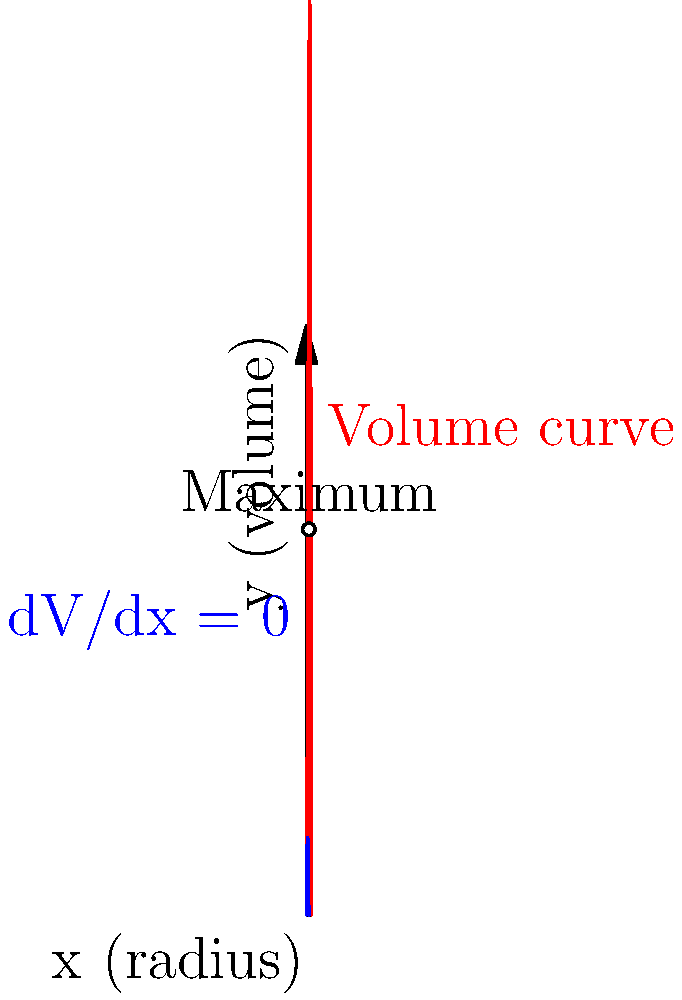A baby bottle manufacturer wants to design a cylindrical bottle with a maximum volume of 1000 mL. The total height and radius of the bottle are constrained such that $h + 2r = 10$ cm, where $h$ is the height and $r$ is the radius. Using calculus, determine the optimal dimensions (radius and height) of the bottle to maximize its volume. Round your answer to the nearest 0.1 cm. Let's approach this step-by-step:

1) The volume of a cylinder is given by $V = \pi r^2 h$.

2) We know that $h + 2r = 10$, so $h = 10 - 2r$.

3) Substituting this into the volume equation:
   $V = \pi r^2 (10 - 2r) = 10\pi r^2 - 2\pi r^3$

4) To find the maximum volume, we need to find where $\frac{dV}{dr} = 0$:
   $\frac{dV}{dr} = 20\pi r - 6\pi r^2$

5) Setting this equal to zero:
   $20\pi r - 6\pi r^2 = 0$
   $2r(10 - 3r) = 0$

6) Solving this equation:
   $r = 0$ or $r = \frac{10}{3}$

7) $r = 0$ would give us no volume, so the maximum must occur at $r = \frac{10}{3} \approx 3.33$ cm.

8) To find the height, we use $h = 10 - 2r$:
   $h = 10 - 2(\frac{10}{3}) = \frac{10}{3} \approx 3.33$ cm

9) Rounding to the nearest 0.1 cm:
   $r \approx 3.3$ cm and $h \approx 3.3$ cm

10) We can verify this is a maximum by checking the second derivative is negative at this point.
Answer: Radius ≈ 3.3 cm, Height ≈ 3.3 cm 